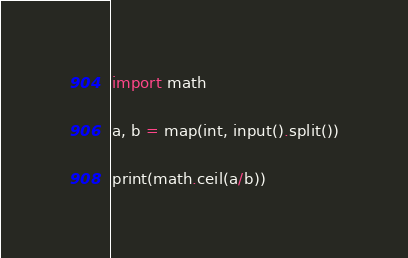<code> <loc_0><loc_0><loc_500><loc_500><_Python_>import math

a, b = map(int, input().split())

print(math.ceil(a/b))</code> 